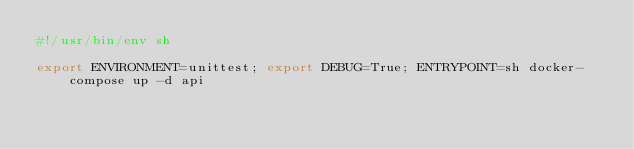Convert code to text. <code><loc_0><loc_0><loc_500><loc_500><_Bash_>#!/usr/bin/env sh

export ENVIRONMENT=unittest; export DEBUG=True; ENTRYPOINT=sh docker-compose up -d api
</code> 